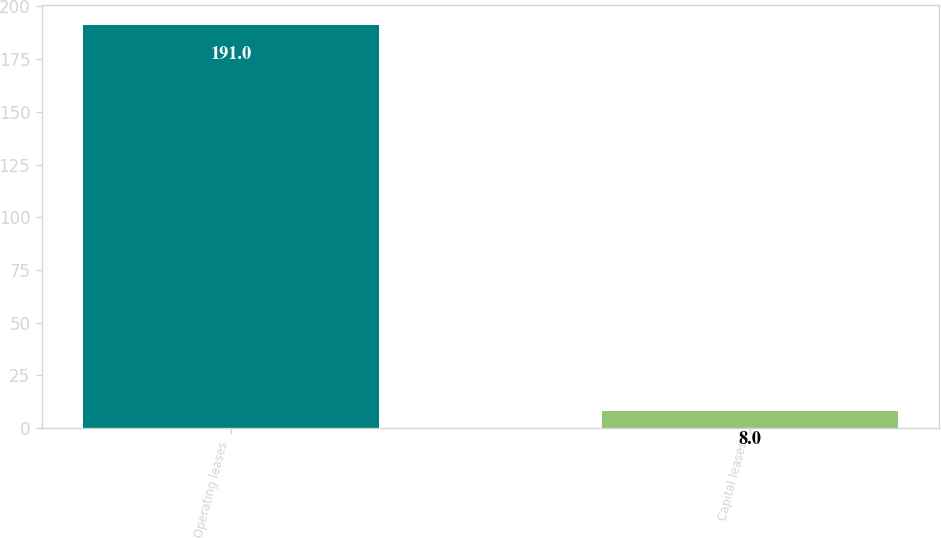Convert chart. <chart><loc_0><loc_0><loc_500><loc_500><bar_chart><fcel>Operating leases<fcel>Capital leases<nl><fcel>191<fcel>8<nl></chart> 